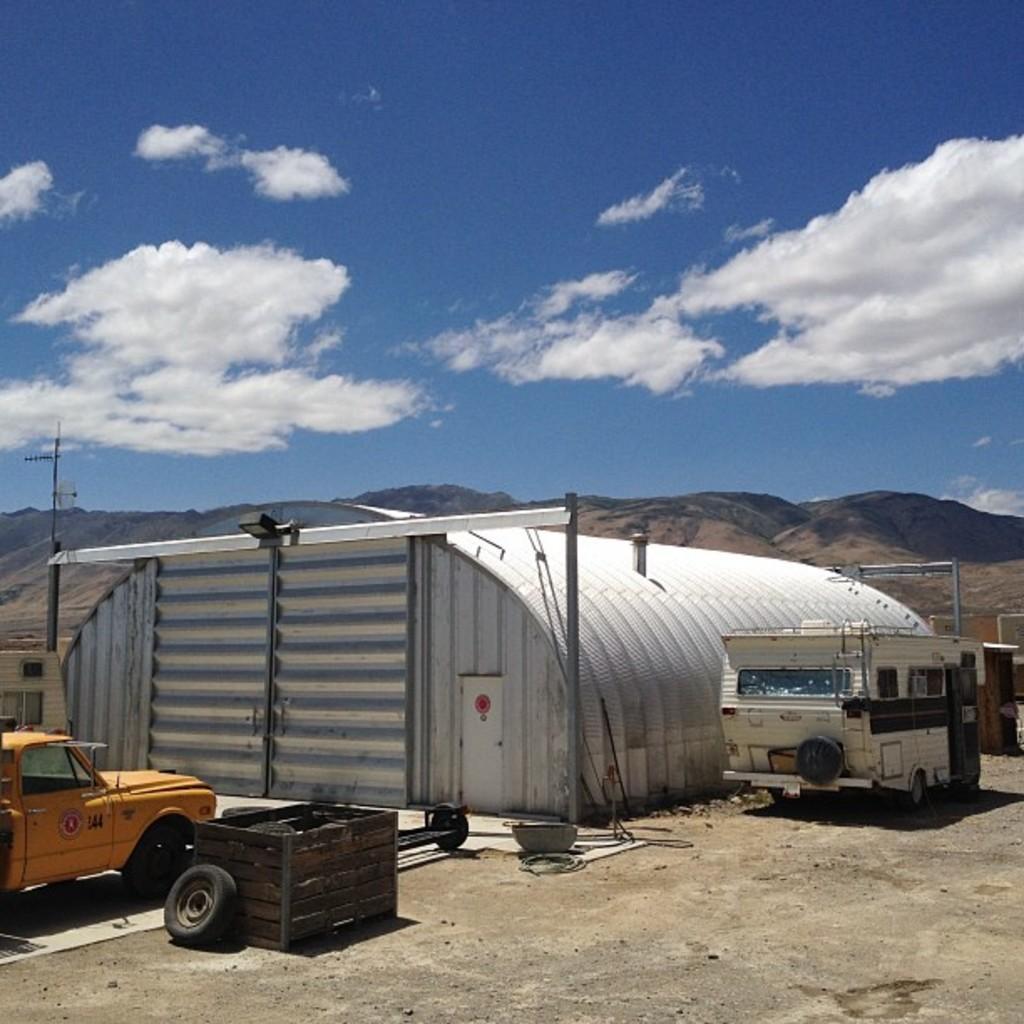In one or two sentences, can you explain what this image depicts? In this picture there is a shed, beside that there is a truck. On the left there is a car near to the wooden box and wheel. In the background we can see the mountains. At the top we can see the sky and clouds. 